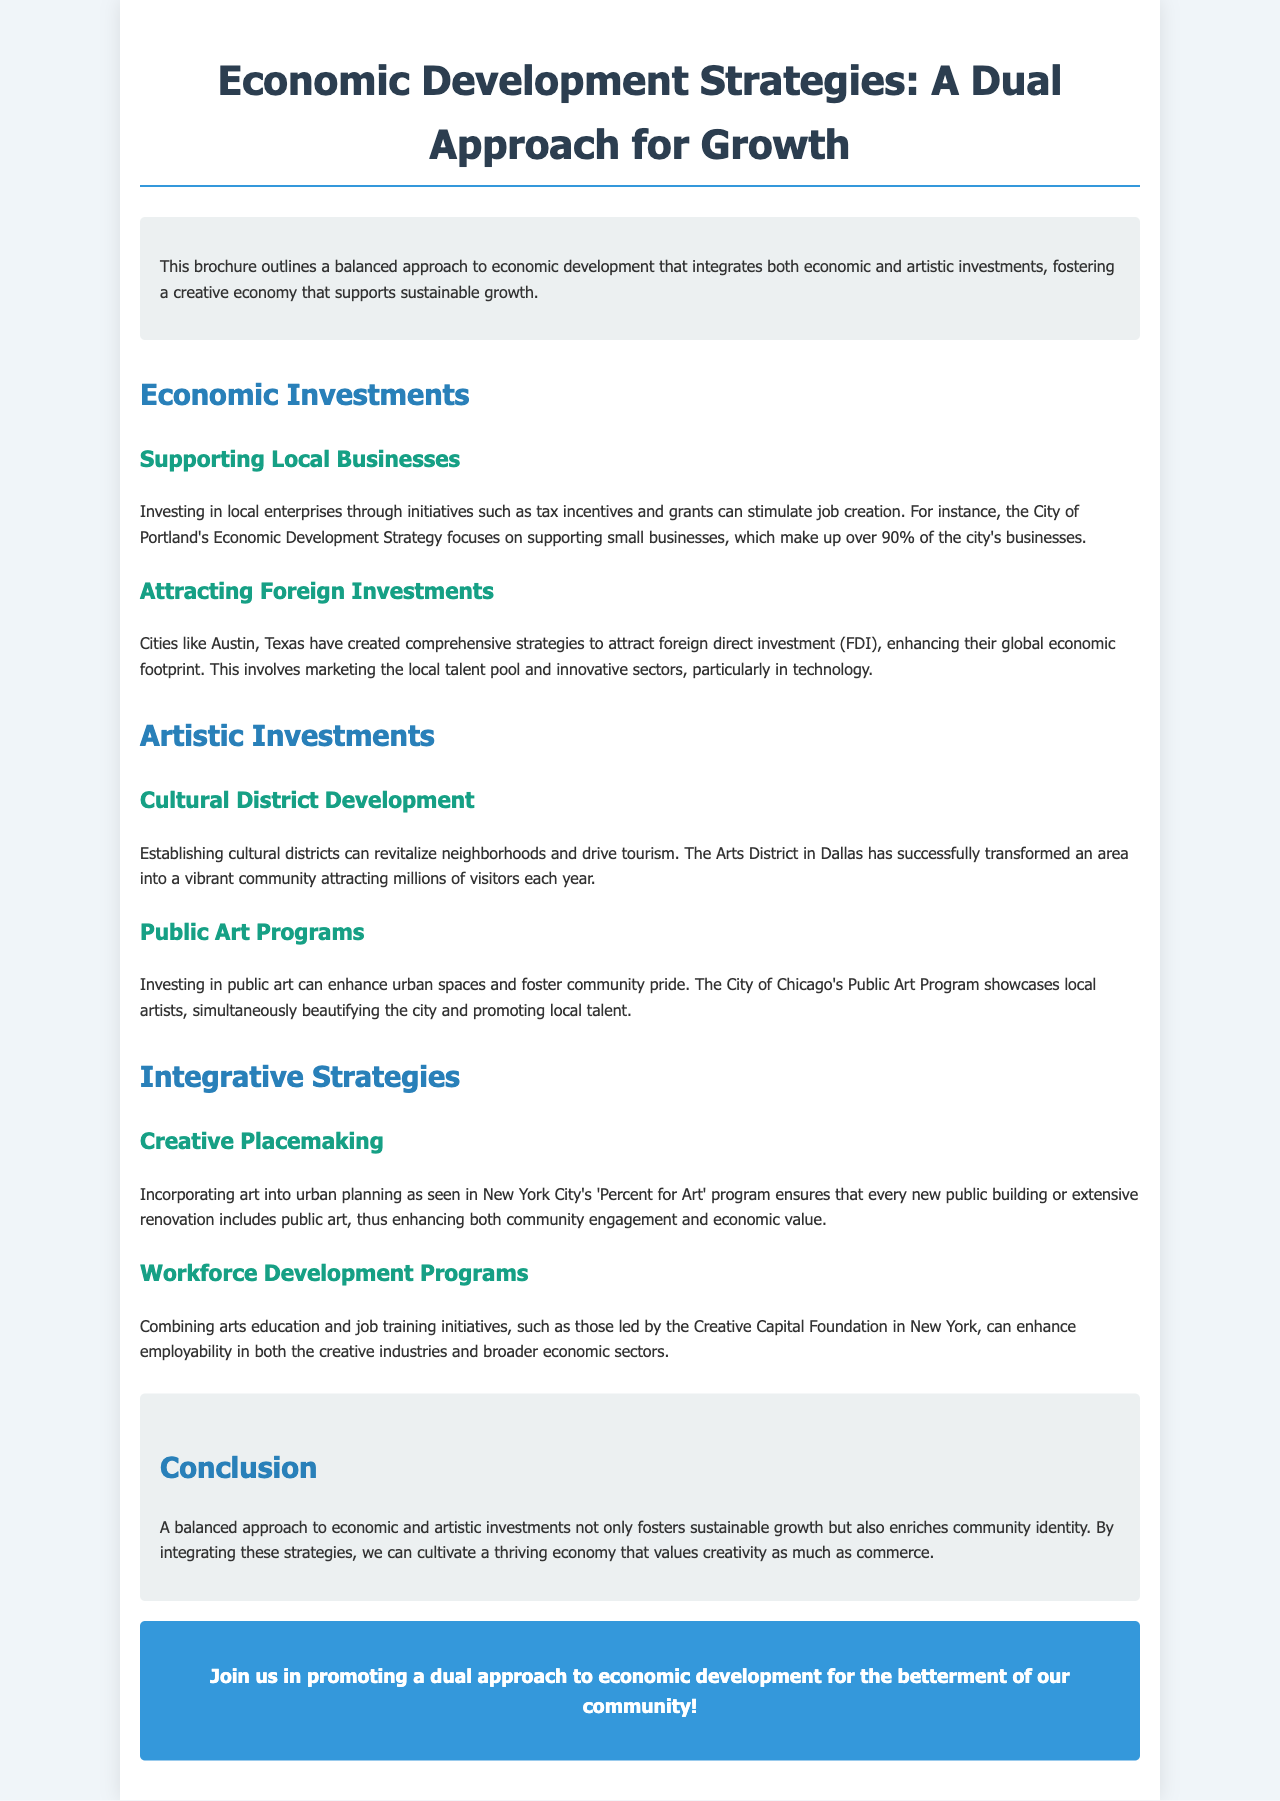What is the title of the document? The title of the document is given prominently at the top of the brochure.
Answer: Economic Development Strategies: A Dual Approach for Growth What department in Portland focuses on small businesses? The document mentions that the City of Portland's Economic Development Strategy focuses on this area.
Answer: Economic Development Strategy How many businesses in Portland are small businesses? The document states that over 90% of the city's businesses are classified as such.
Answer: Over 90% What cultural district is mentioned in the document? The document specifically talks about a well-known area renowned for its successful cultural development.
Answer: Arts District in Dallas What program incorporates public art into urban planning? The document identifies a specific program in New York City that governs this integration.
Answer: Percent for Art What type of programs are combined with arts education in workforce development? The document refers to job training initiatives that work alongside arts education.
Answer: Job training initiatives What is the main benefit of integrating economic and artistic investments according to the conclusion? The conclusion highlights the positive outcome of this integration on community identity.
Answer: Community identity What is the call to action at the end of the brochure? The document ends with a statement aimed at encouraging community involvement in the discussed approach.
Answer: Join us in promoting a dual approach to economic development for the betterment of our community! 